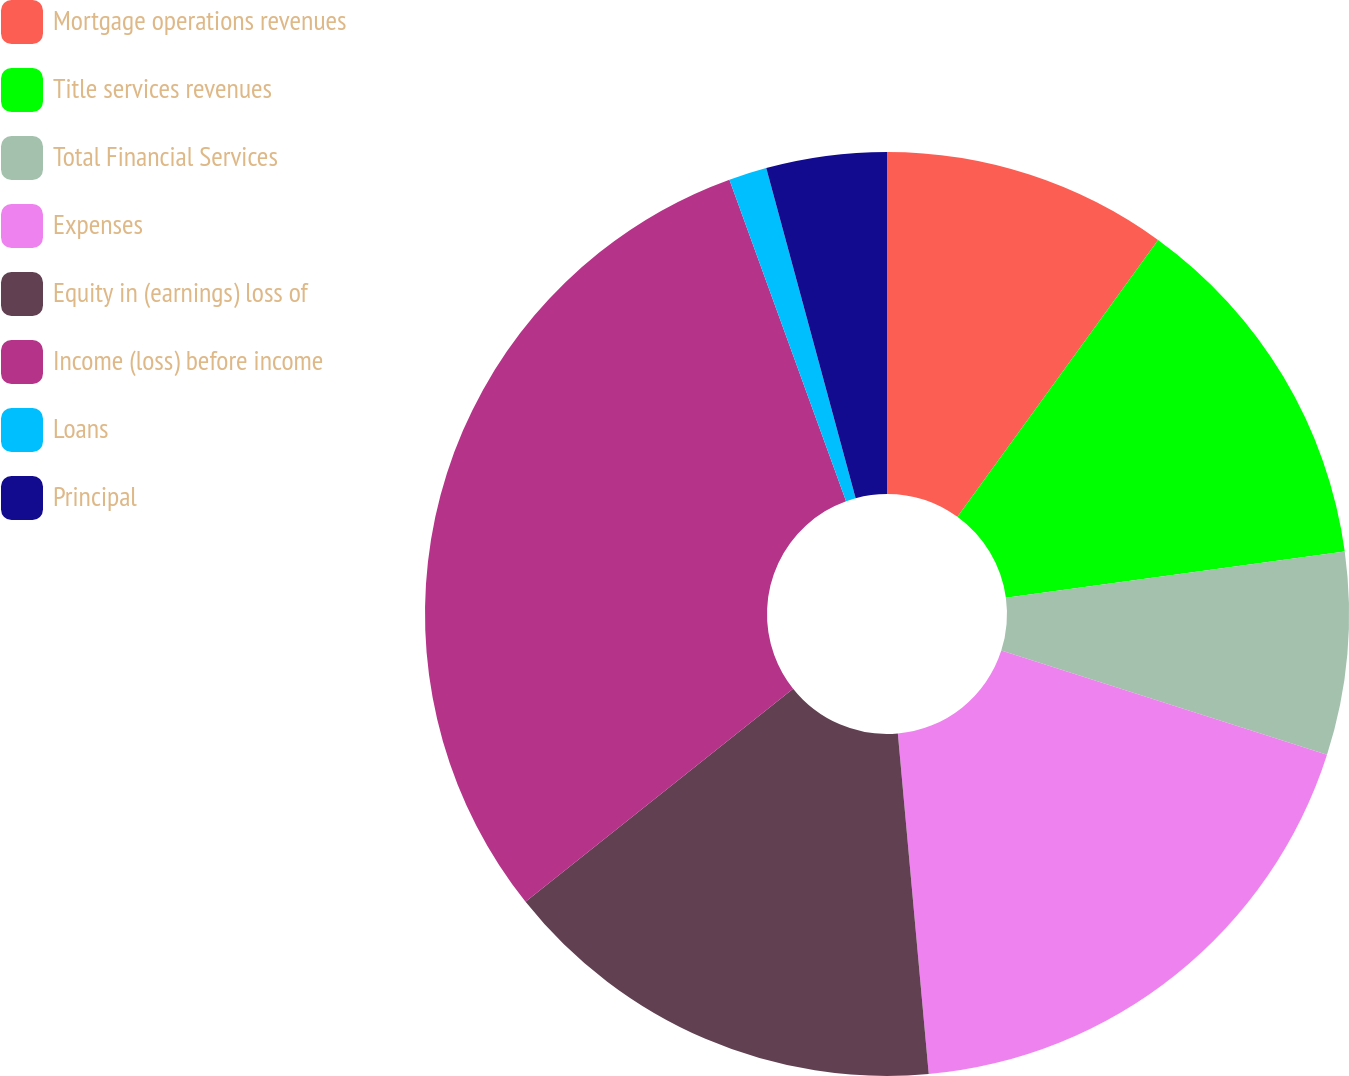Convert chart to OTSL. <chart><loc_0><loc_0><loc_500><loc_500><pie_chart><fcel>Mortgage operations revenues<fcel>Title services revenues<fcel>Total Financial Services<fcel>Expenses<fcel>Equity in (earnings) loss of<fcel>Income (loss) before income<fcel>Loans<fcel>Principal<nl><fcel>9.98%<fcel>12.86%<fcel>7.09%<fcel>18.63%<fcel>15.74%<fcel>30.16%<fcel>1.33%<fcel>4.21%<nl></chart> 